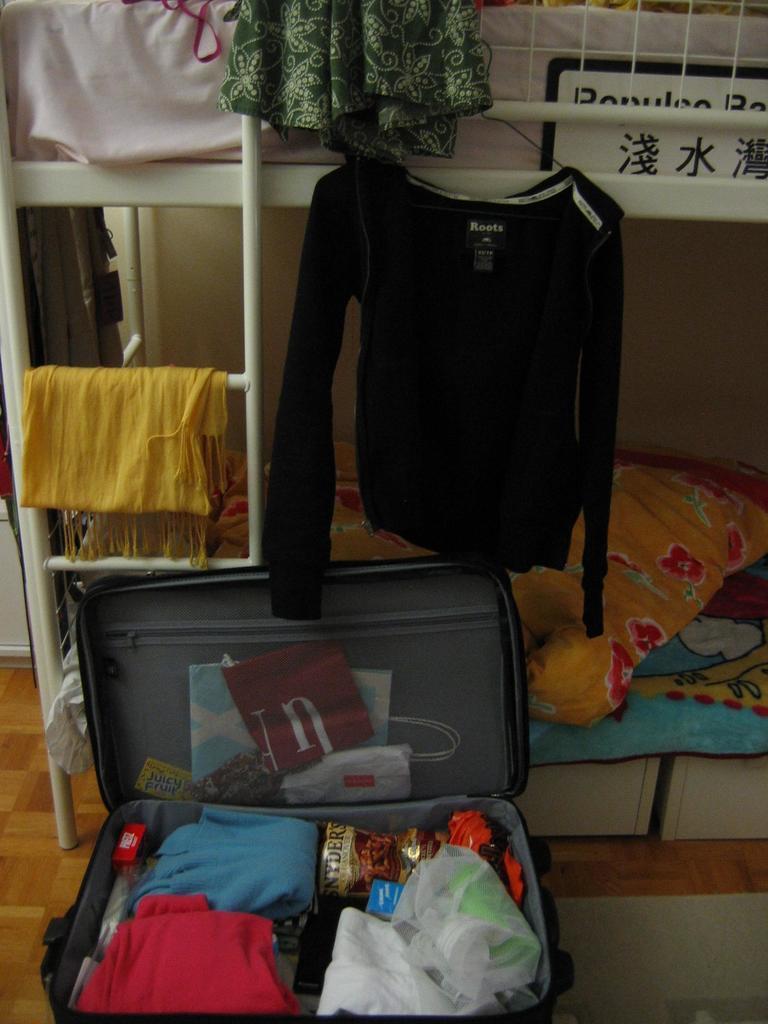Could you give a brief overview of what you see in this image? In this picture we can see a briefcase and clothes in it and also we can see a bed. 